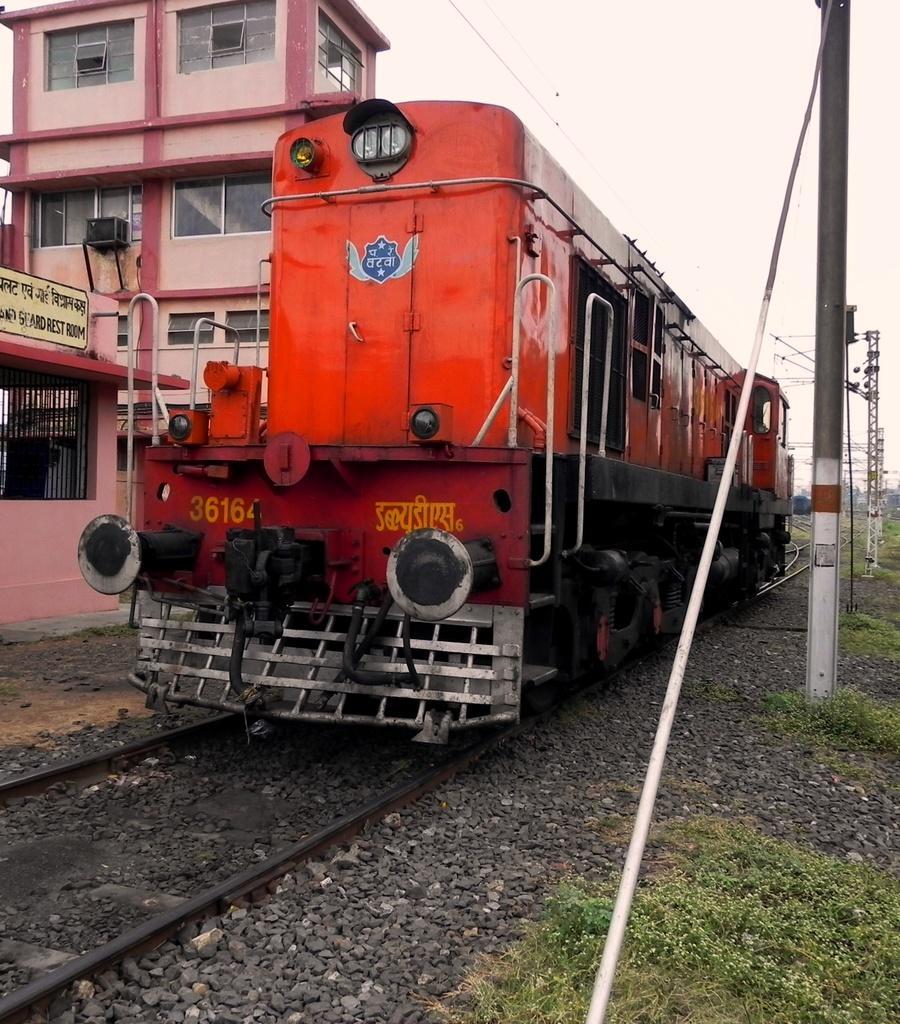Please provide a concise description of this image. In the picture I can see a train engine on the railway track. I can see the electric poles on the right side. I can see the stones on the side of the railway track on the right side. I can see a house on the left side and I can see the glass windows of a house. 